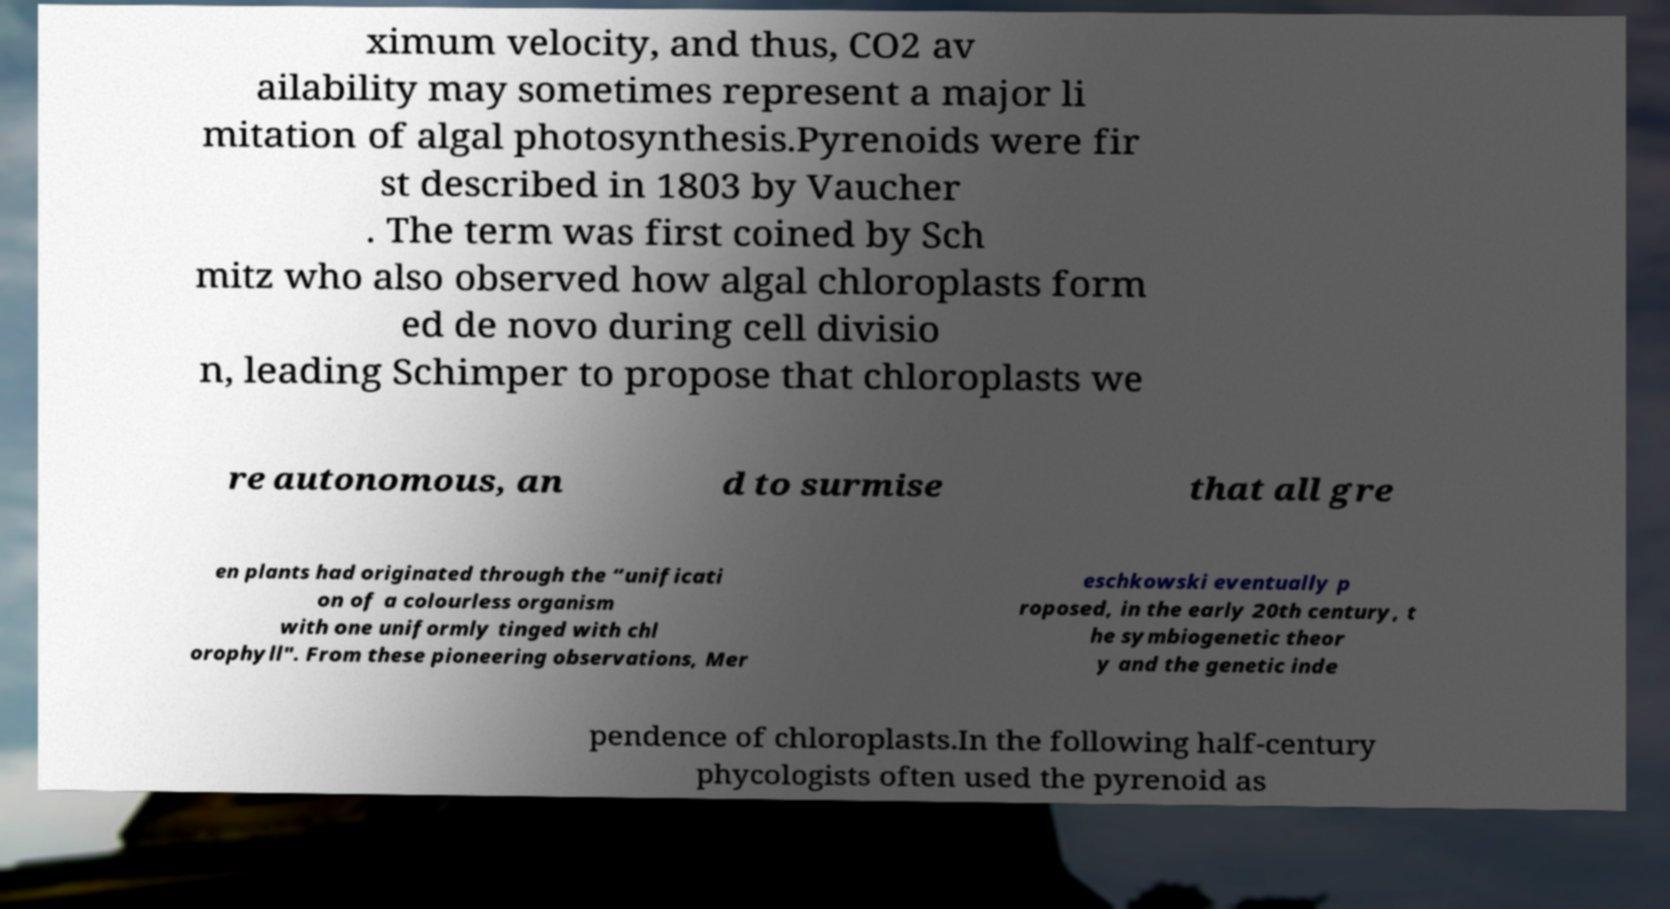Can you accurately transcribe the text from the provided image for me? ximum velocity, and thus, CO2 av ailability may sometimes represent a major li mitation of algal photosynthesis.Pyrenoids were fir st described in 1803 by Vaucher . The term was first coined by Sch mitz who also observed how algal chloroplasts form ed de novo during cell divisio n, leading Schimper to propose that chloroplasts we re autonomous, an d to surmise that all gre en plants had originated through the “unificati on of a colourless organism with one uniformly tinged with chl orophyll". From these pioneering observations, Mer eschkowski eventually p roposed, in the early 20th century, t he symbiogenetic theor y and the genetic inde pendence of chloroplasts.In the following half-century phycologists often used the pyrenoid as 